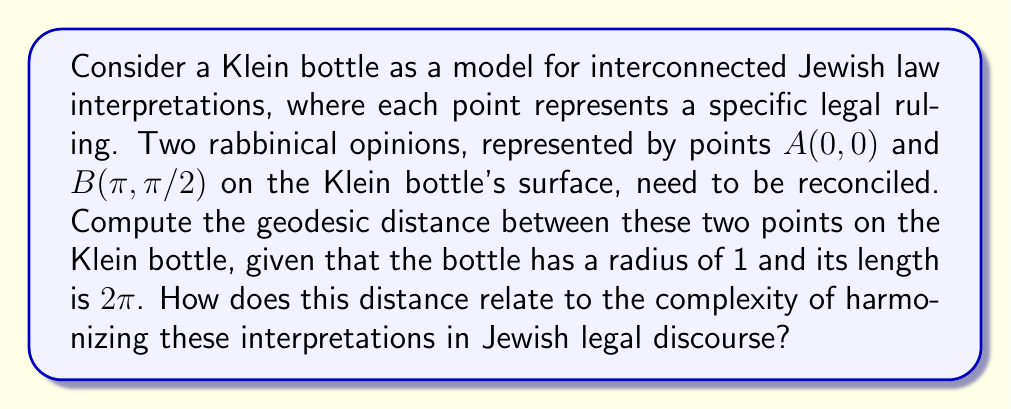What is the answer to this math problem? To solve this problem, we need to understand the geometry of a Klein bottle and how to calculate geodesic distances on its surface. This approach metaphorically represents the interconnectedness and sometimes paradoxical nature of Jewish law interpretations.

1) First, recall that a Klein bottle can be represented as a rectangle with specific edge identifications. The metric on a Klein bottle with radius 1 and length 2π can be given by:

   $$ds^2 = du^2 + dv^2$$

   where $0 \leq u < 2\pi$ and $0 \leq v < \pi$.

2) The points A(0, 0) and B(π, π/2) are given in these (u, v) coordinates.

3) On a Klein bottle, the shortest path (geodesic) between two points can be found by considering multiple paths due to the bottle's non-orientable nature. We need to consider:
   a) The direct path
   b) The path crossing the "seam" of the Klein bottle

4) For the direct path:
   $$d_1 = \sqrt{(\pi - 0)^2 + (\pi/2 - 0)^2} = \sqrt{\pi^2 + (\pi/2)^2} = \pi\sqrt{5}/2$$

5) For the path crossing the seam:
   $$d_2 = \sqrt{(\pi - 0)^2 + (\pi/2 - \pi)^2} = \sqrt{\pi^2 + (\pi/2)^2} = \pi\sqrt{5}/2$$

6) The geodesic distance is the minimum of these two paths:

   $$d = \min(d_1, d_2) = \pi\sqrt{5}/2$$

This distance metaphorically represents the complexity of reconciling these two rabbinical opinions. The fact that both paths yield the same distance could be interpreted as the equal validity of different approaches in Jewish legal discourse, reflecting the multifaceted nature of Halakhic interpretation as studied by scholars like Philip S. Alexander.
Answer: The geodesic distance between points A(0, 0) and B(π, π/2) on the Klein bottle is $\frac{\pi\sqrt{5}}{2}$. 